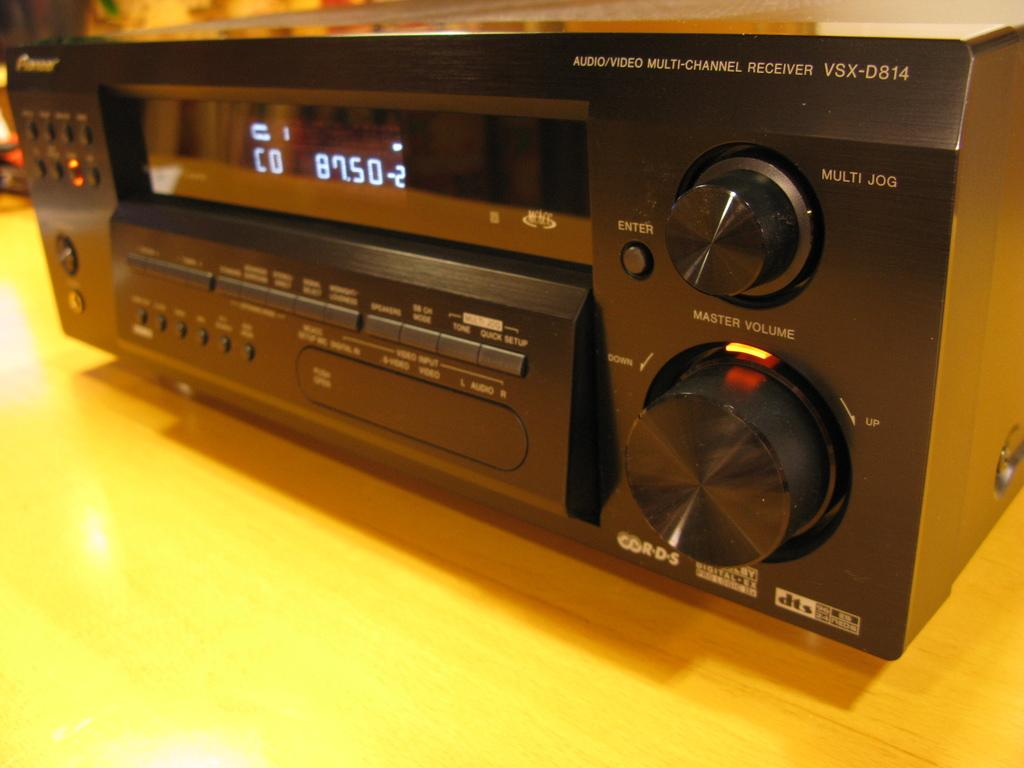What is the main object in the picture? There is a music player in the picture. What features does the music player have? The music player has a display screen and buttons. Where is the music player located? The music player is placed on a wooden table. What type of trees can be seen in the background of the image? There are no trees visible in the image; it only features a music player on a wooden table. What is the topic of the discussion taking place in the image? There is no discussion taking place in the image; it only shows a music player on a wooden table. 